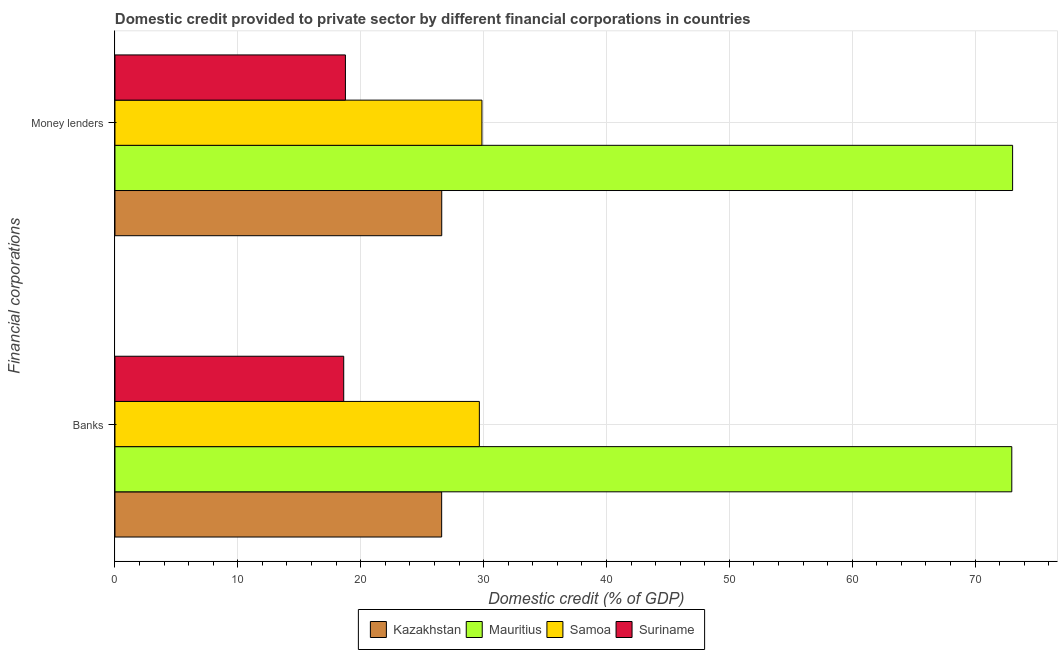How many groups of bars are there?
Your answer should be very brief. 2. Are the number of bars per tick equal to the number of legend labels?
Give a very brief answer. Yes. What is the label of the 1st group of bars from the top?
Make the answer very short. Money lenders. What is the domestic credit provided by banks in Suriname?
Offer a terse response. 18.62. Across all countries, what is the maximum domestic credit provided by banks?
Provide a short and direct response. 72.99. Across all countries, what is the minimum domestic credit provided by banks?
Your answer should be compact. 18.62. In which country was the domestic credit provided by banks maximum?
Keep it short and to the point. Mauritius. In which country was the domestic credit provided by banks minimum?
Offer a terse response. Suriname. What is the total domestic credit provided by money lenders in the graph?
Keep it short and to the point. 148.27. What is the difference between the domestic credit provided by money lenders in Kazakhstan and that in Suriname?
Your answer should be very brief. 7.84. What is the difference between the domestic credit provided by banks in Suriname and the domestic credit provided by money lenders in Mauritius?
Your answer should be compact. -54.44. What is the average domestic credit provided by money lenders per country?
Your answer should be compact. 37.07. What is the difference between the domestic credit provided by banks and domestic credit provided by money lenders in Mauritius?
Your answer should be compact. -0.07. What is the ratio of the domestic credit provided by money lenders in Mauritius to that in Kazakhstan?
Make the answer very short. 2.75. Is the domestic credit provided by banks in Samoa less than that in Suriname?
Offer a very short reply. No. In how many countries, is the domestic credit provided by money lenders greater than the average domestic credit provided by money lenders taken over all countries?
Your answer should be compact. 1. What does the 4th bar from the top in Banks represents?
Your answer should be very brief. Kazakhstan. What does the 1st bar from the bottom in Money lenders represents?
Ensure brevity in your answer.  Kazakhstan. How many bars are there?
Your answer should be very brief. 8. How many countries are there in the graph?
Your response must be concise. 4. Does the graph contain any zero values?
Your answer should be compact. No. Does the graph contain grids?
Give a very brief answer. Yes. How many legend labels are there?
Provide a succinct answer. 4. How are the legend labels stacked?
Your answer should be compact. Horizontal. What is the title of the graph?
Make the answer very short. Domestic credit provided to private sector by different financial corporations in countries. What is the label or title of the X-axis?
Offer a terse response. Domestic credit (% of GDP). What is the label or title of the Y-axis?
Offer a terse response. Financial corporations. What is the Domestic credit (% of GDP) in Kazakhstan in Banks?
Give a very brief answer. 26.59. What is the Domestic credit (% of GDP) in Mauritius in Banks?
Give a very brief answer. 72.99. What is the Domestic credit (% of GDP) of Samoa in Banks?
Offer a very short reply. 29.66. What is the Domestic credit (% of GDP) of Suriname in Banks?
Give a very brief answer. 18.62. What is the Domestic credit (% of GDP) in Kazakhstan in Money lenders?
Your answer should be compact. 26.59. What is the Domestic credit (% of GDP) of Mauritius in Money lenders?
Your answer should be compact. 73.05. What is the Domestic credit (% of GDP) of Samoa in Money lenders?
Offer a very short reply. 29.87. What is the Domestic credit (% of GDP) in Suriname in Money lenders?
Offer a very short reply. 18.76. Across all Financial corporations, what is the maximum Domestic credit (% of GDP) in Kazakhstan?
Offer a terse response. 26.59. Across all Financial corporations, what is the maximum Domestic credit (% of GDP) of Mauritius?
Keep it short and to the point. 73.05. Across all Financial corporations, what is the maximum Domestic credit (% of GDP) of Samoa?
Ensure brevity in your answer.  29.87. Across all Financial corporations, what is the maximum Domestic credit (% of GDP) of Suriname?
Your answer should be very brief. 18.76. Across all Financial corporations, what is the minimum Domestic credit (% of GDP) in Kazakhstan?
Offer a very short reply. 26.59. Across all Financial corporations, what is the minimum Domestic credit (% of GDP) of Mauritius?
Keep it short and to the point. 72.99. Across all Financial corporations, what is the minimum Domestic credit (% of GDP) in Samoa?
Make the answer very short. 29.66. Across all Financial corporations, what is the minimum Domestic credit (% of GDP) of Suriname?
Your answer should be compact. 18.62. What is the total Domestic credit (% of GDP) in Kazakhstan in the graph?
Offer a very short reply. 53.18. What is the total Domestic credit (% of GDP) in Mauritius in the graph?
Offer a very short reply. 146.04. What is the total Domestic credit (% of GDP) in Samoa in the graph?
Offer a terse response. 59.52. What is the total Domestic credit (% of GDP) of Suriname in the graph?
Provide a succinct answer. 37.37. What is the difference between the Domestic credit (% of GDP) of Kazakhstan in Banks and that in Money lenders?
Offer a terse response. -0.01. What is the difference between the Domestic credit (% of GDP) in Mauritius in Banks and that in Money lenders?
Your answer should be very brief. -0.07. What is the difference between the Domestic credit (% of GDP) in Samoa in Banks and that in Money lenders?
Your answer should be very brief. -0.21. What is the difference between the Domestic credit (% of GDP) of Suriname in Banks and that in Money lenders?
Offer a terse response. -0.14. What is the difference between the Domestic credit (% of GDP) in Kazakhstan in Banks and the Domestic credit (% of GDP) in Mauritius in Money lenders?
Your response must be concise. -46.47. What is the difference between the Domestic credit (% of GDP) in Kazakhstan in Banks and the Domestic credit (% of GDP) in Samoa in Money lenders?
Your response must be concise. -3.28. What is the difference between the Domestic credit (% of GDP) in Kazakhstan in Banks and the Domestic credit (% of GDP) in Suriname in Money lenders?
Make the answer very short. 7.83. What is the difference between the Domestic credit (% of GDP) in Mauritius in Banks and the Domestic credit (% of GDP) in Samoa in Money lenders?
Your answer should be very brief. 43.12. What is the difference between the Domestic credit (% of GDP) in Mauritius in Banks and the Domestic credit (% of GDP) in Suriname in Money lenders?
Give a very brief answer. 54.23. What is the difference between the Domestic credit (% of GDP) in Samoa in Banks and the Domestic credit (% of GDP) in Suriname in Money lenders?
Provide a short and direct response. 10.9. What is the average Domestic credit (% of GDP) in Kazakhstan per Financial corporations?
Make the answer very short. 26.59. What is the average Domestic credit (% of GDP) of Mauritius per Financial corporations?
Offer a very short reply. 73.02. What is the average Domestic credit (% of GDP) of Samoa per Financial corporations?
Provide a succinct answer. 29.76. What is the average Domestic credit (% of GDP) in Suriname per Financial corporations?
Provide a short and direct response. 18.69. What is the difference between the Domestic credit (% of GDP) in Kazakhstan and Domestic credit (% of GDP) in Mauritius in Banks?
Offer a very short reply. -46.4. What is the difference between the Domestic credit (% of GDP) in Kazakhstan and Domestic credit (% of GDP) in Samoa in Banks?
Ensure brevity in your answer.  -3.07. What is the difference between the Domestic credit (% of GDP) of Kazakhstan and Domestic credit (% of GDP) of Suriname in Banks?
Provide a succinct answer. 7.97. What is the difference between the Domestic credit (% of GDP) of Mauritius and Domestic credit (% of GDP) of Samoa in Banks?
Your answer should be very brief. 43.33. What is the difference between the Domestic credit (% of GDP) of Mauritius and Domestic credit (% of GDP) of Suriname in Banks?
Your response must be concise. 54.37. What is the difference between the Domestic credit (% of GDP) in Samoa and Domestic credit (% of GDP) in Suriname in Banks?
Provide a succinct answer. 11.04. What is the difference between the Domestic credit (% of GDP) of Kazakhstan and Domestic credit (% of GDP) of Mauritius in Money lenders?
Make the answer very short. -46.46. What is the difference between the Domestic credit (% of GDP) in Kazakhstan and Domestic credit (% of GDP) in Samoa in Money lenders?
Your response must be concise. -3.27. What is the difference between the Domestic credit (% of GDP) of Kazakhstan and Domestic credit (% of GDP) of Suriname in Money lenders?
Offer a terse response. 7.84. What is the difference between the Domestic credit (% of GDP) in Mauritius and Domestic credit (% of GDP) in Samoa in Money lenders?
Offer a very short reply. 43.19. What is the difference between the Domestic credit (% of GDP) in Mauritius and Domestic credit (% of GDP) in Suriname in Money lenders?
Provide a short and direct response. 54.3. What is the difference between the Domestic credit (% of GDP) in Samoa and Domestic credit (% of GDP) in Suriname in Money lenders?
Offer a terse response. 11.11. What is the ratio of the Domestic credit (% of GDP) of Kazakhstan in Banks to that in Money lenders?
Your answer should be very brief. 1. What is the ratio of the Domestic credit (% of GDP) in Mauritius in Banks to that in Money lenders?
Ensure brevity in your answer.  1. What is the ratio of the Domestic credit (% of GDP) of Samoa in Banks to that in Money lenders?
Offer a very short reply. 0.99. What is the ratio of the Domestic credit (% of GDP) in Suriname in Banks to that in Money lenders?
Your answer should be very brief. 0.99. What is the difference between the highest and the second highest Domestic credit (% of GDP) of Kazakhstan?
Ensure brevity in your answer.  0.01. What is the difference between the highest and the second highest Domestic credit (% of GDP) in Mauritius?
Give a very brief answer. 0.07. What is the difference between the highest and the second highest Domestic credit (% of GDP) in Samoa?
Your answer should be very brief. 0.21. What is the difference between the highest and the second highest Domestic credit (% of GDP) of Suriname?
Your answer should be very brief. 0.14. What is the difference between the highest and the lowest Domestic credit (% of GDP) in Kazakhstan?
Ensure brevity in your answer.  0.01. What is the difference between the highest and the lowest Domestic credit (% of GDP) of Mauritius?
Your answer should be compact. 0.07. What is the difference between the highest and the lowest Domestic credit (% of GDP) of Samoa?
Make the answer very short. 0.21. What is the difference between the highest and the lowest Domestic credit (% of GDP) of Suriname?
Your answer should be very brief. 0.14. 